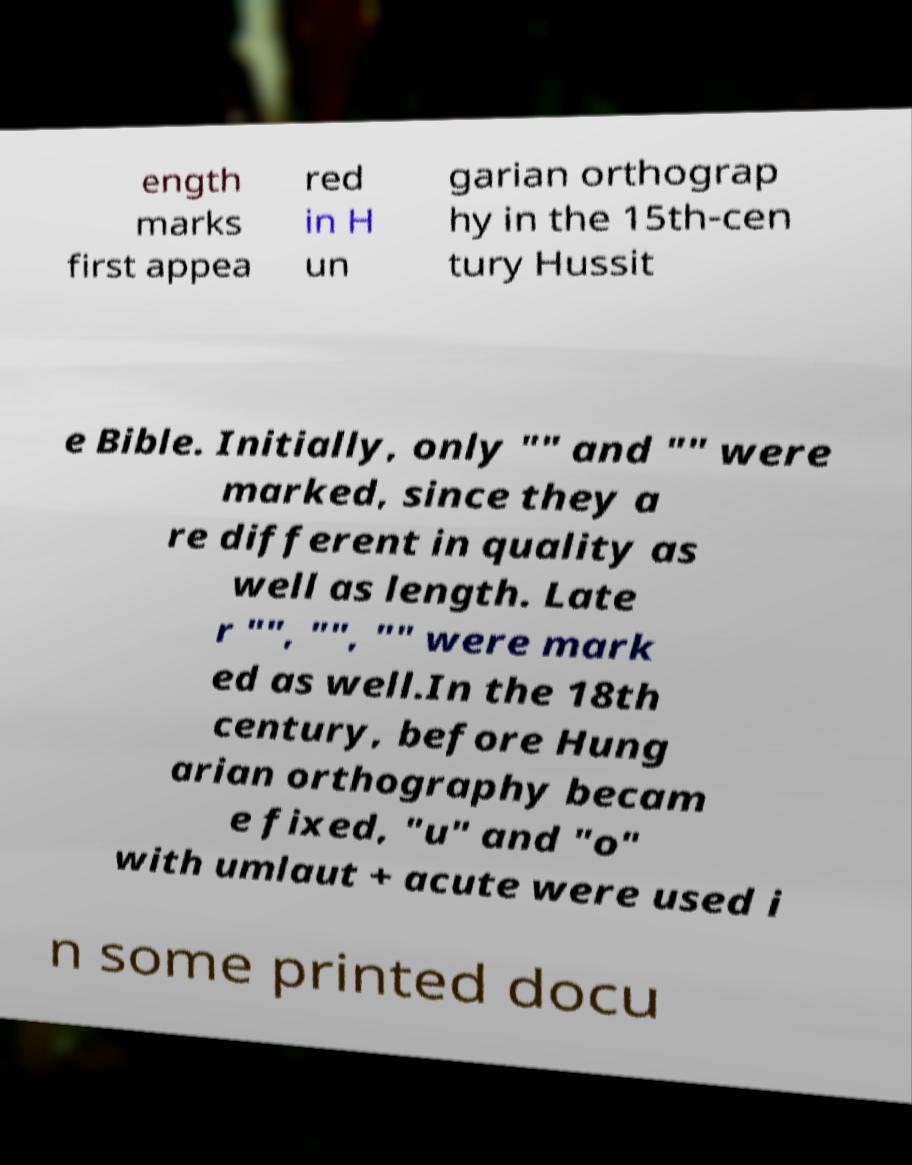Can you read and provide the text displayed in the image?This photo seems to have some interesting text. Can you extract and type it out for me? ength marks first appea red in H un garian orthograp hy in the 15th-cen tury Hussit e Bible. Initially, only "" and "" were marked, since they a re different in quality as well as length. Late r "", "", "" were mark ed as well.In the 18th century, before Hung arian orthography becam e fixed, "u" and "o" with umlaut + acute were used i n some printed docu 